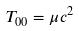<formula> <loc_0><loc_0><loc_500><loc_500>T _ { 0 0 } = \mu c ^ { 2 }</formula> 